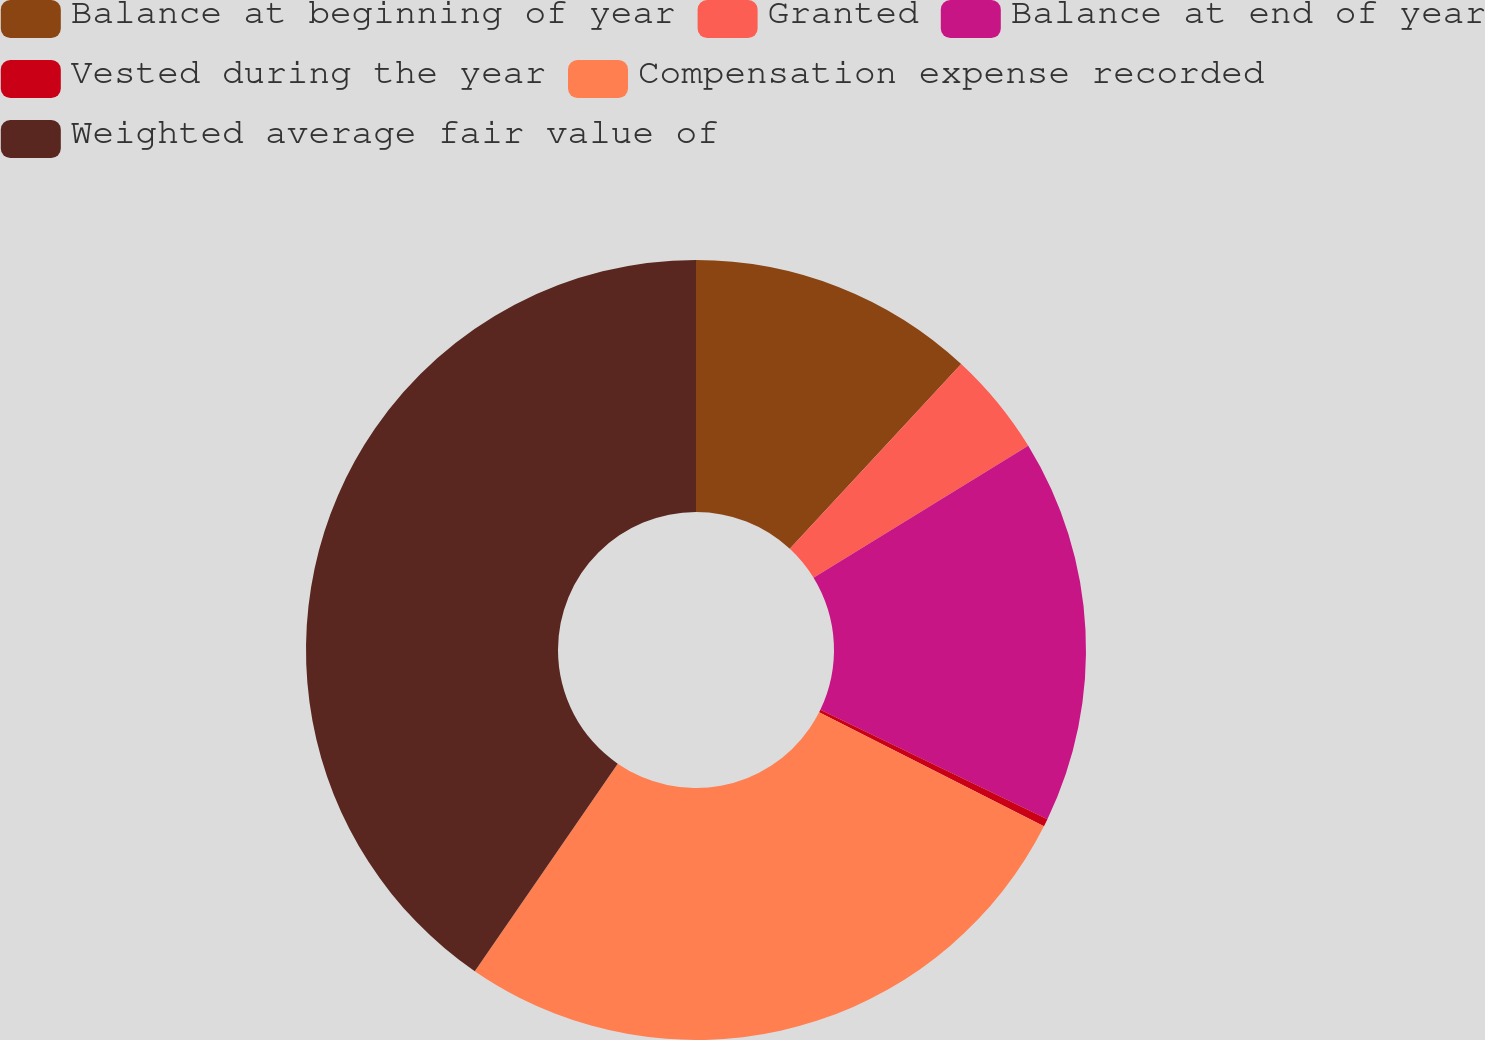Convert chart to OTSL. <chart><loc_0><loc_0><loc_500><loc_500><pie_chart><fcel>Balance at beginning of year<fcel>Granted<fcel>Balance at end of year<fcel>Vested during the year<fcel>Compensation expense recorded<fcel>Weighted average fair value of<nl><fcel>11.9%<fcel>4.33%<fcel>15.91%<fcel>0.32%<fcel>27.14%<fcel>40.4%<nl></chart> 